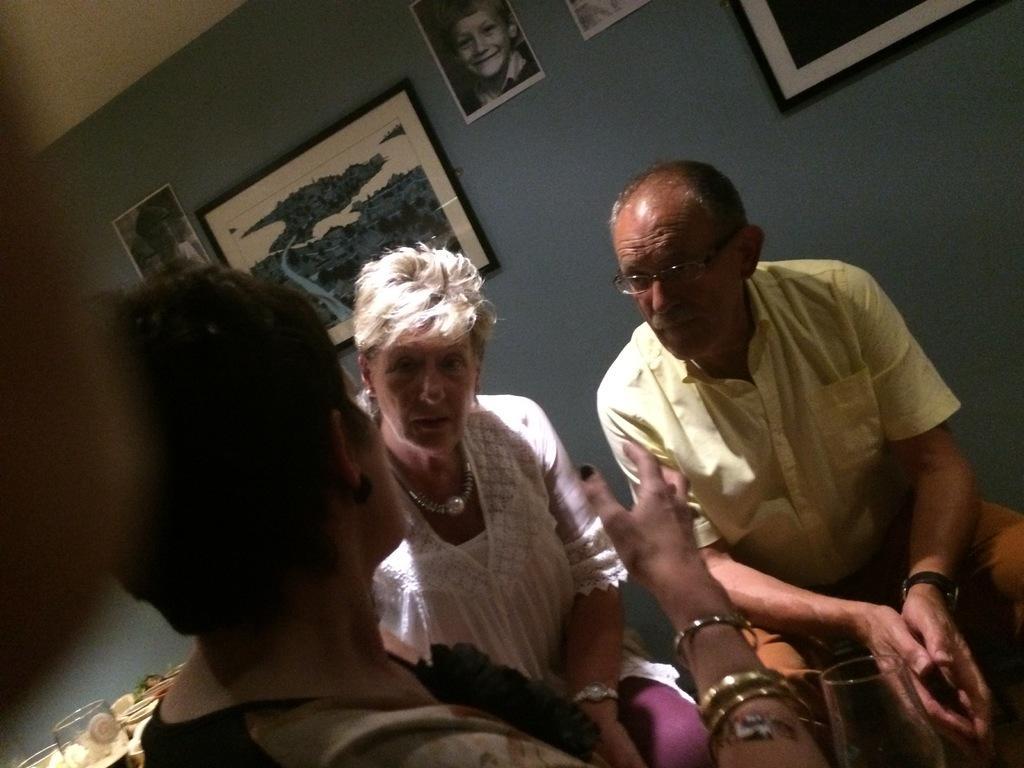Describe this image in one or two sentences. In this image we can see three persons. Here we can see glasses and few objects. In the background we can see wall, frames, and photographs. 